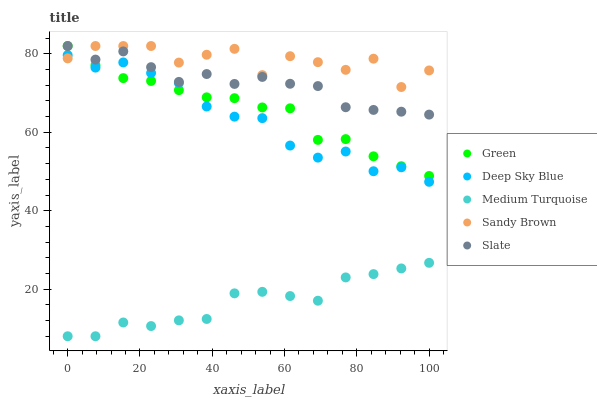Does Medium Turquoise have the minimum area under the curve?
Answer yes or no. Yes. Does Sandy Brown have the maximum area under the curve?
Answer yes or no. Yes. Does Slate have the minimum area under the curve?
Answer yes or no. No. Does Slate have the maximum area under the curve?
Answer yes or no. No. Is Green the smoothest?
Answer yes or no. Yes. Is Sandy Brown the roughest?
Answer yes or no. Yes. Is Slate the smoothest?
Answer yes or no. No. Is Slate the roughest?
Answer yes or no. No. Does Medium Turquoise have the lowest value?
Answer yes or no. Yes. Does Slate have the lowest value?
Answer yes or no. No. Does Green have the highest value?
Answer yes or no. Yes. Does Medium Turquoise have the highest value?
Answer yes or no. No. Is Medium Turquoise less than Green?
Answer yes or no. Yes. Is Sandy Brown greater than Medium Turquoise?
Answer yes or no. Yes. Does Green intersect Sandy Brown?
Answer yes or no. Yes. Is Green less than Sandy Brown?
Answer yes or no. No. Is Green greater than Sandy Brown?
Answer yes or no. No. Does Medium Turquoise intersect Green?
Answer yes or no. No. 